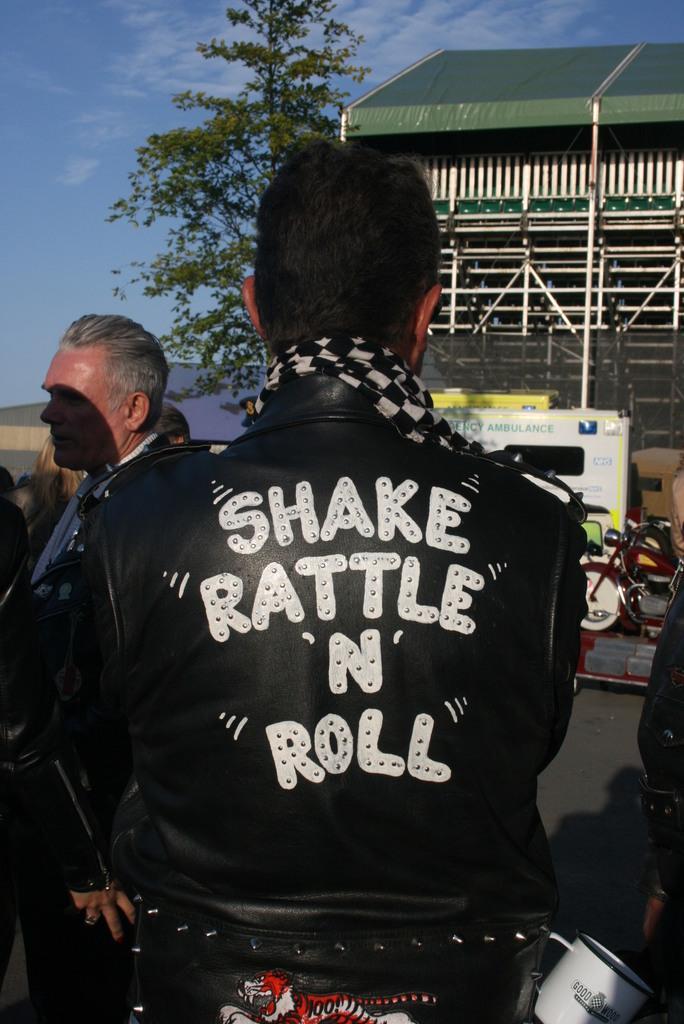Can you describe this image briefly? In this picture we can see a man wearing a black jacket with something written on it. In front of him we can see a house and a tree. Here the sky is blue. 